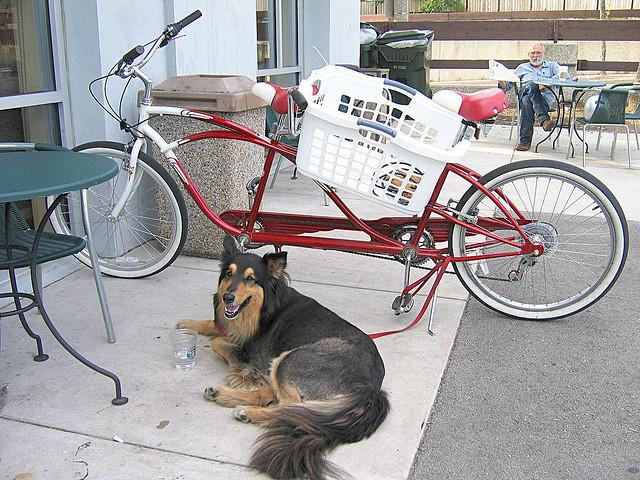What is the bike being used to transport? laundry 